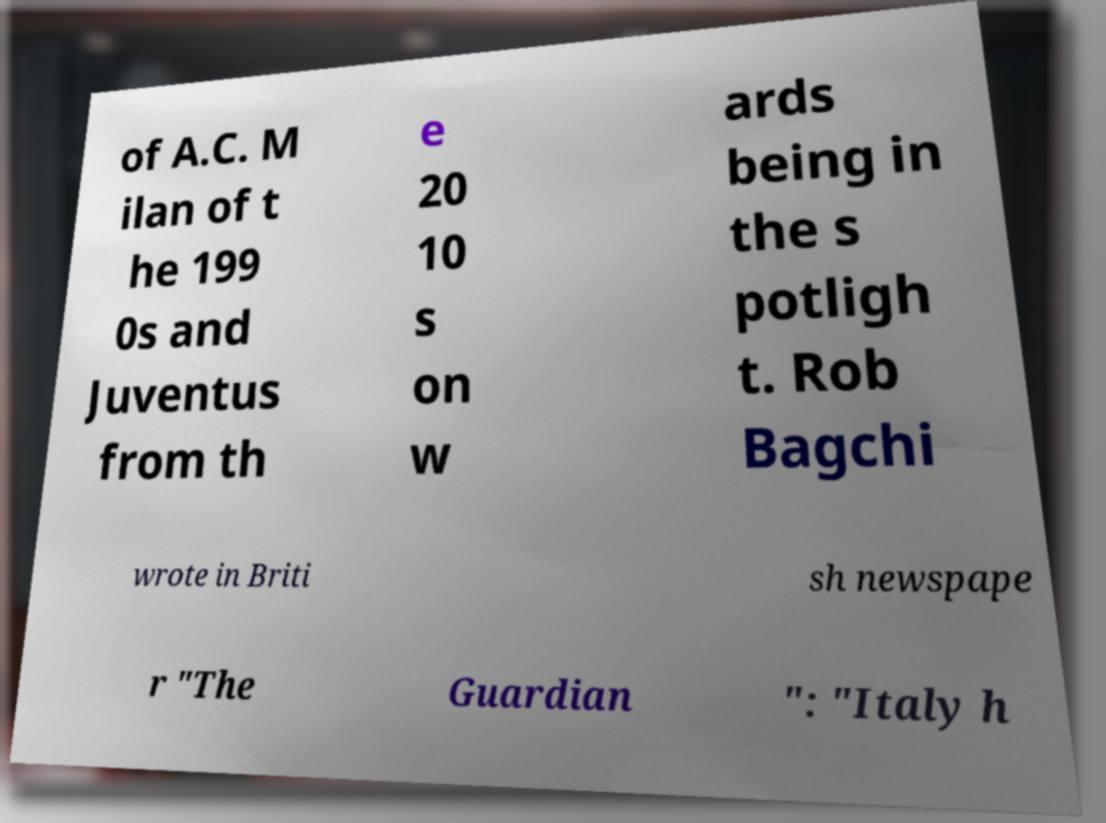There's text embedded in this image that I need extracted. Can you transcribe it verbatim? of A.C. M ilan of t he 199 0s and Juventus from th e 20 10 s on w ards being in the s potligh t. Rob Bagchi wrote in Briti sh newspape r "The Guardian ": "Italy h 